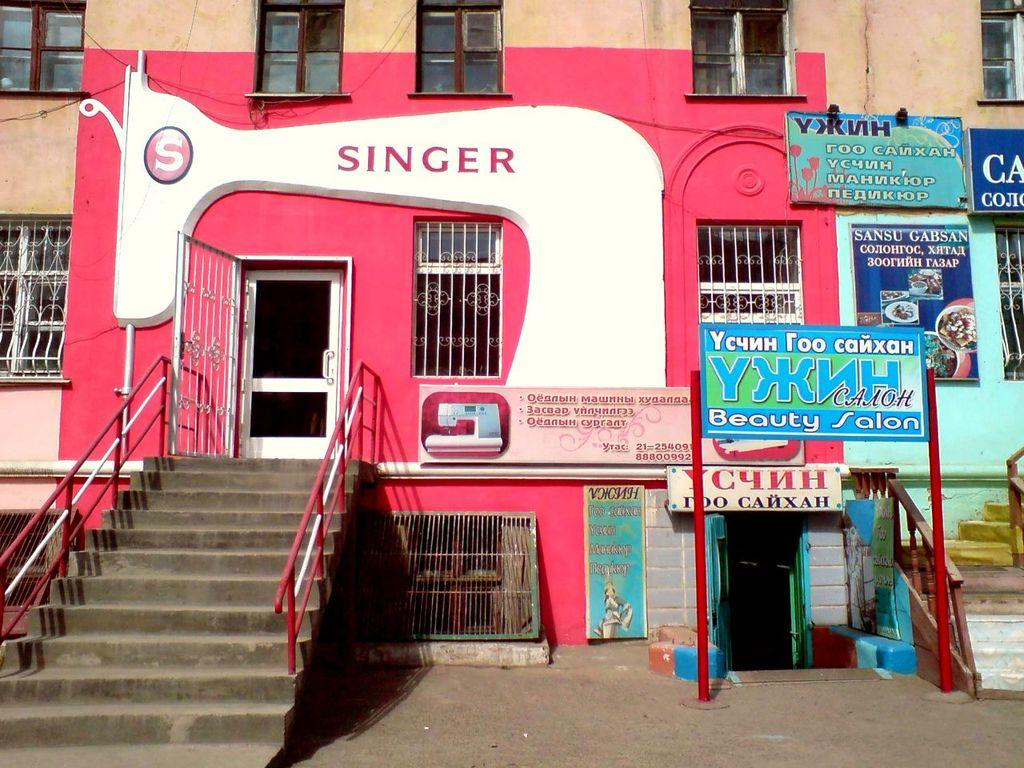What type of architectural feature is present in the image? There are steps in the image. What structure can be seen on poles in the image? There is a board on poles in the image. What is the background of the image made of? There is a wall in the image. What can be seen in the wall in the image? There are windows in the image. What type of material is present in the image? There are boards in the image. Where is the oven located in the image? There is no oven present in the image. What type of clothing accessory is draped over the board on poles? There is no clothing accessory, such as a veil, present in the image. 